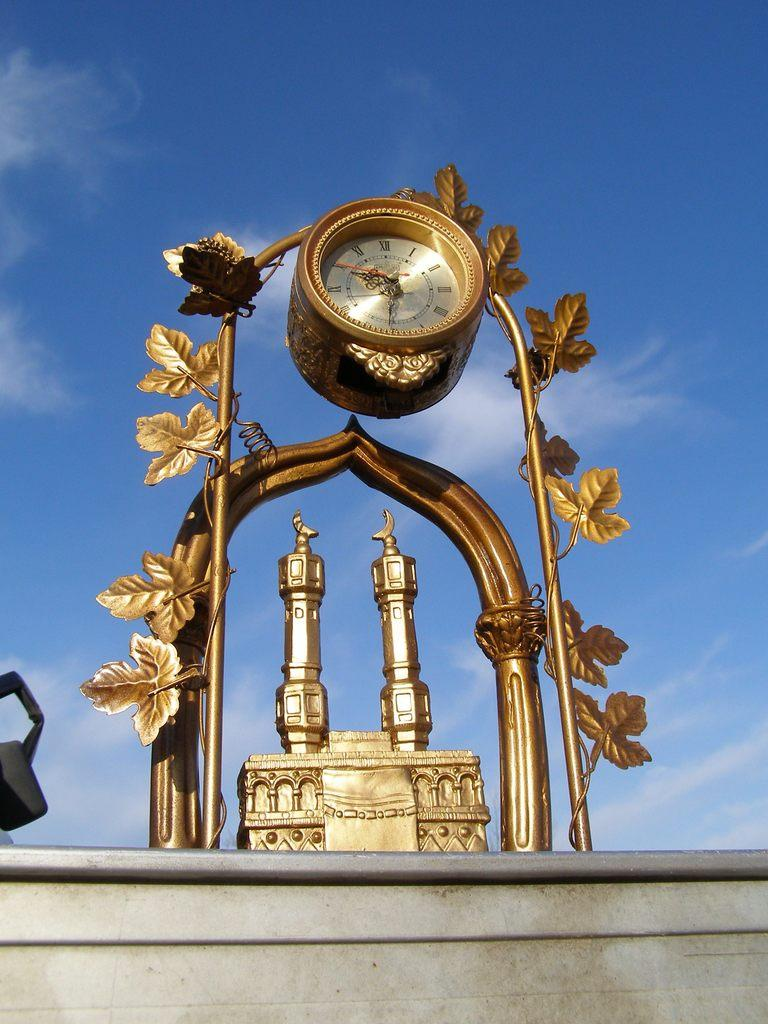<image>
Create a compact narrative representing the image presented. An outdoor clock with the time 10:30 on its face. 